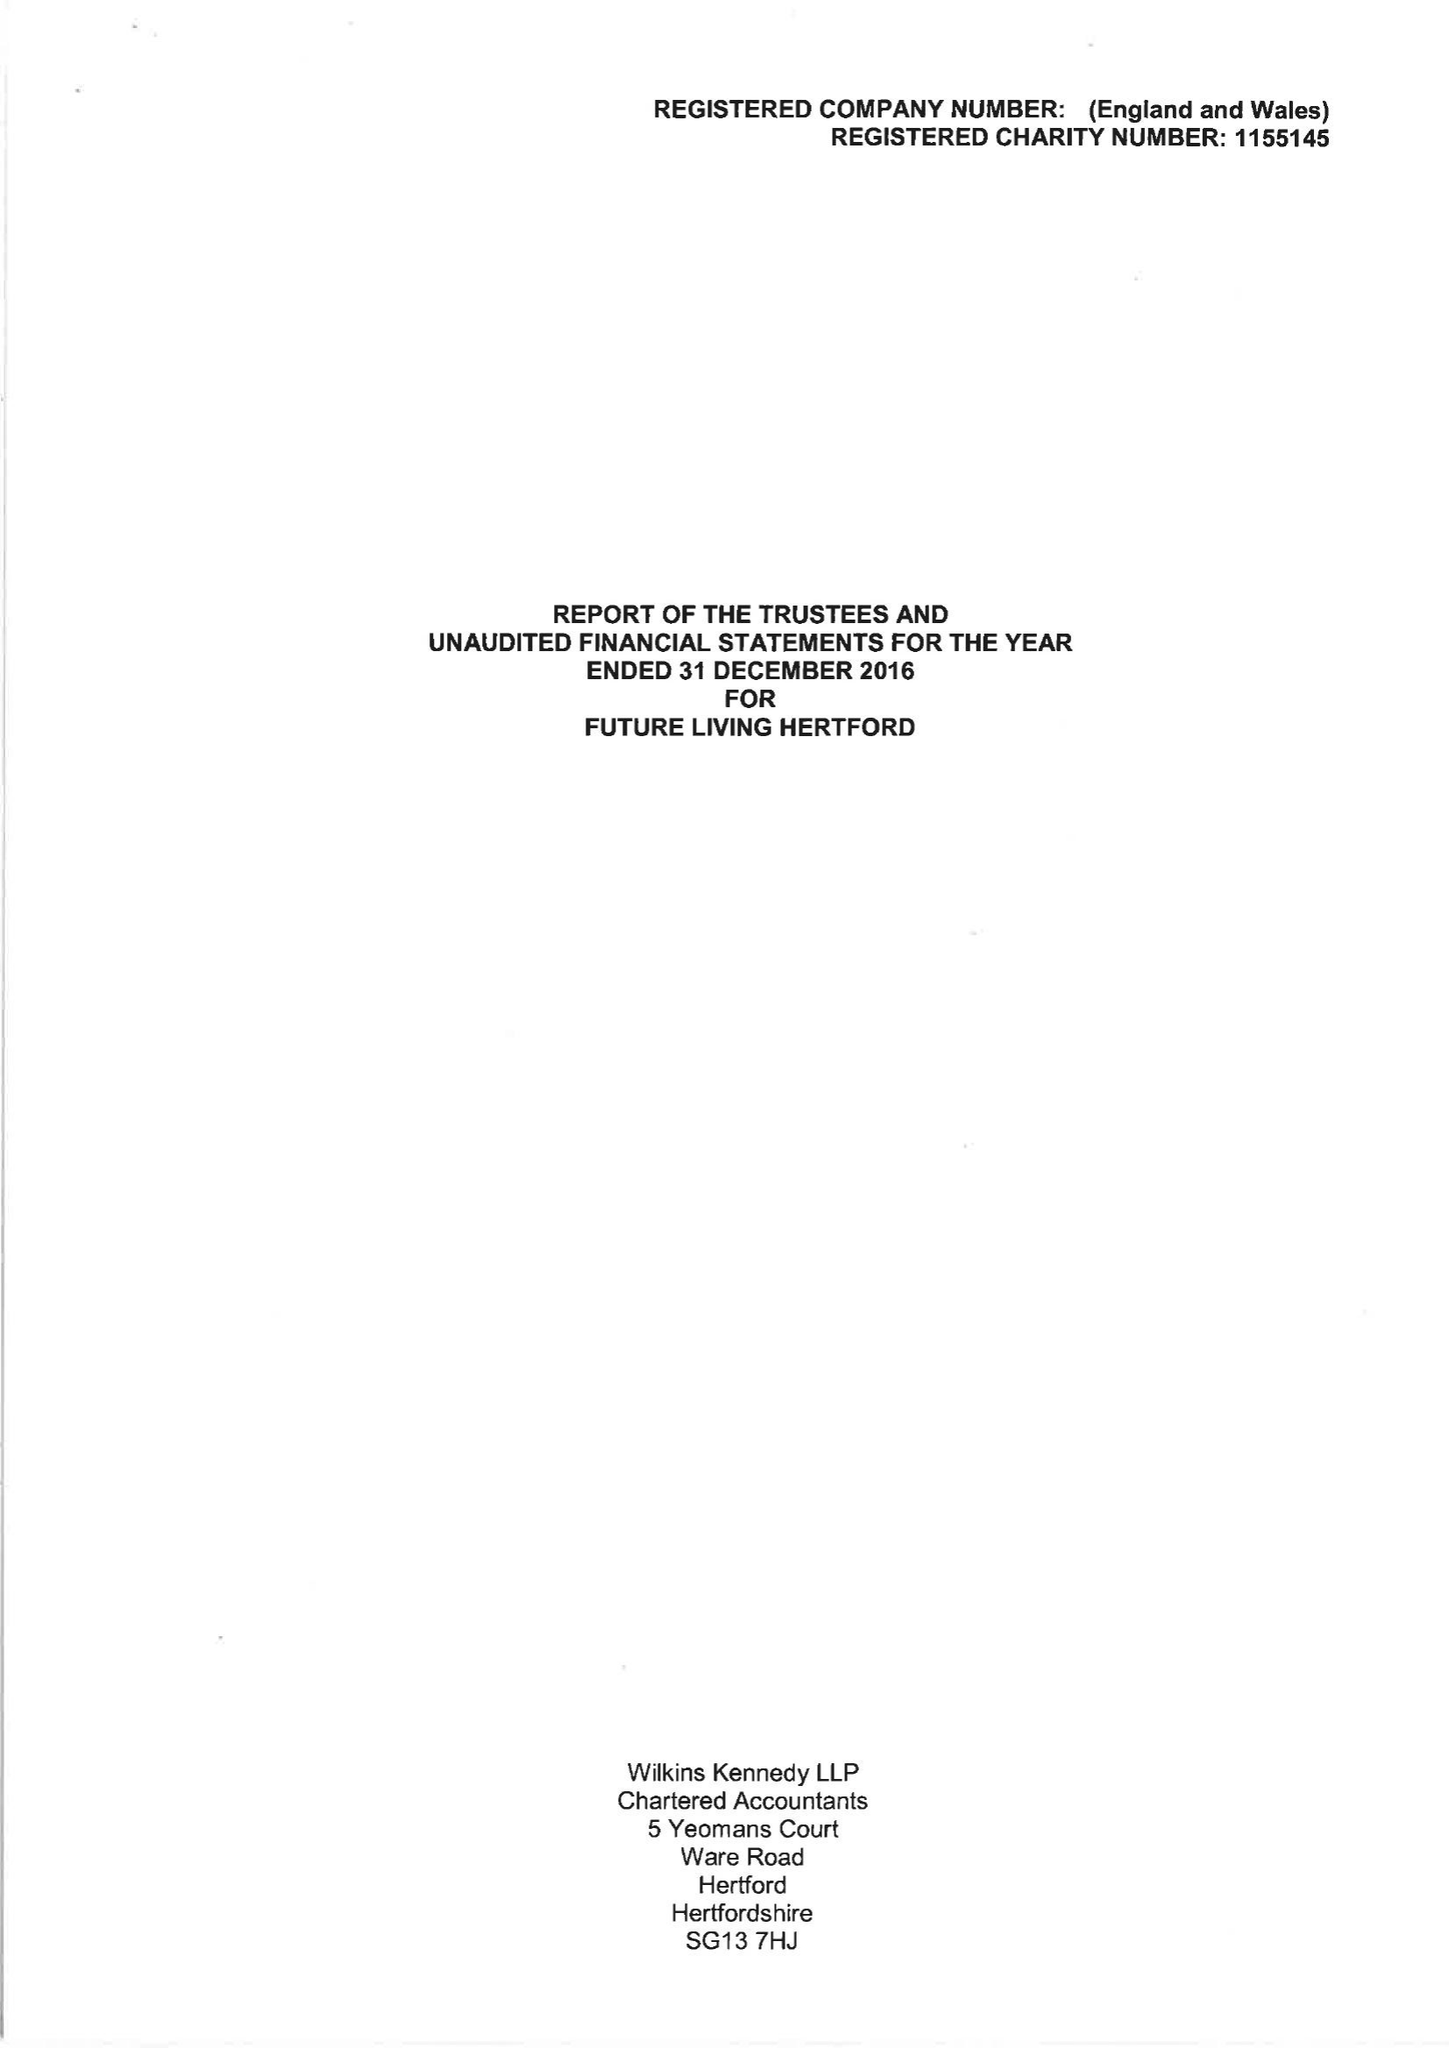What is the value for the address__post_town?
Answer the question using a single word or phrase. HERTFORD 